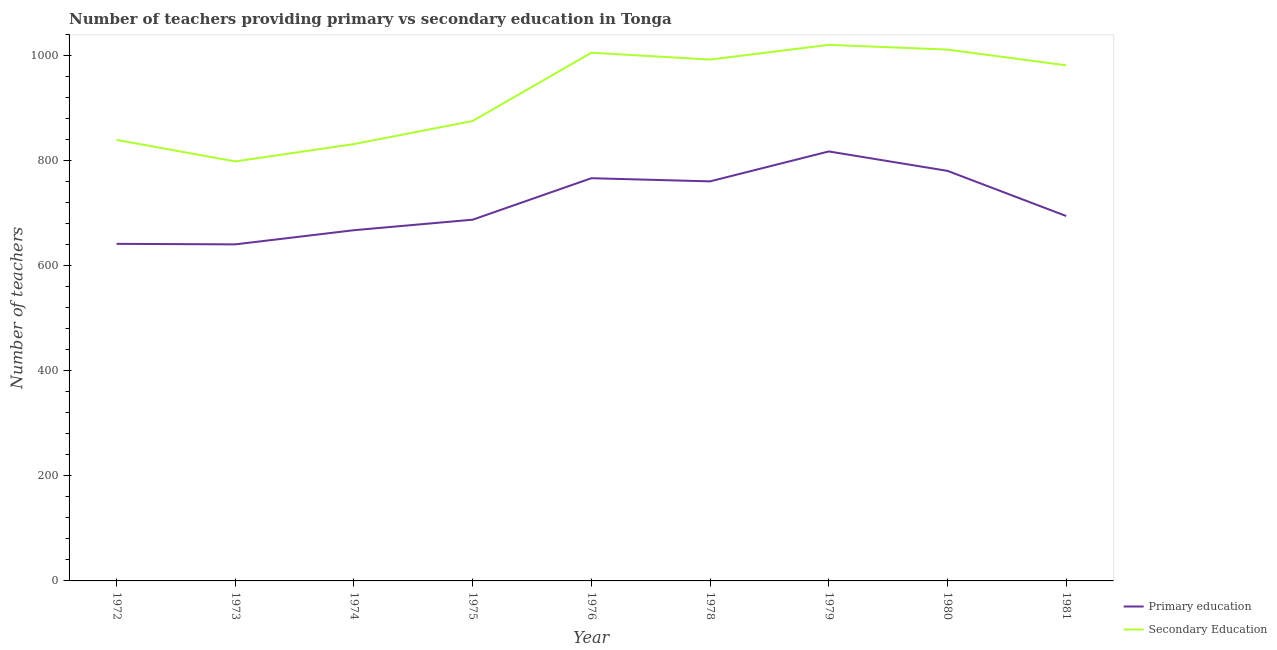How many different coloured lines are there?
Offer a very short reply. 2. Does the line corresponding to number of primary teachers intersect with the line corresponding to number of secondary teachers?
Your response must be concise. No. What is the number of primary teachers in 1975?
Offer a terse response. 688. Across all years, what is the maximum number of primary teachers?
Give a very brief answer. 818. Across all years, what is the minimum number of primary teachers?
Keep it short and to the point. 641. In which year was the number of primary teachers maximum?
Keep it short and to the point. 1979. In which year was the number of primary teachers minimum?
Provide a succinct answer. 1973. What is the total number of primary teachers in the graph?
Make the answer very short. 6461. What is the difference between the number of primary teachers in 1974 and that in 1975?
Make the answer very short. -20. What is the difference between the number of secondary teachers in 1978 and the number of primary teachers in 1972?
Offer a very short reply. 351. What is the average number of secondary teachers per year?
Your answer should be compact. 929. In the year 1981, what is the difference between the number of secondary teachers and number of primary teachers?
Give a very brief answer. 287. What is the ratio of the number of secondary teachers in 1980 to that in 1981?
Offer a very short reply. 1.03. What is the difference between the highest and the second highest number of primary teachers?
Provide a succinct answer. 37. What is the difference between the highest and the lowest number of primary teachers?
Give a very brief answer. 177. In how many years, is the number of secondary teachers greater than the average number of secondary teachers taken over all years?
Provide a short and direct response. 5. Does the number of primary teachers monotonically increase over the years?
Your answer should be compact. No. Is the number of secondary teachers strictly greater than the number of primary teachers over the years?
Provide a short and direct response. Yes. Is the number of secondary teachers strictly less than the number of primary teachers over the years?
Your response must be concise. No. How many years are there in the graph?
Your answer should be very brief. 9. Are the values on the major ticks of Y-axis written in scientific E-notation?
Provide a short and direct response. No. Does the graph contain grids?
Offer a terse response. No. Where does the legend appear in the graph?
Give a very brief answer. Bottom right. What is the title of the graph?
Give a very brief answer. Number of teachers providing primary vs secondary education in Tonga. What is the label or title of the X-axis?
Your response must be concise. Year. What is the label or title of the Y-axis?
Provide a succinct answer. Number of teachers. What is the Number of teachers in Primary education in 1972?
Give a very brief answer. 642. What is the Number of teachers of Secondary Education in 1972?
Keep it short and to the point. 840. What is the Number of teachers of Primary education in 1973?
Ensure brevity in your answer.  641. What is the Number of teachers of Secondary Education in 1973?
Ensure brevity in your answer.  799. What is the Number of teachers of Primary education in 1974?
Offer a very short reply. 668. What is the Number of teachers in Secondary Education in 1974?
Your answer should be compact. 832. What is the Number of teachers in Primary education in 1975?
Make the answer very short. 688. What is the Number of teachers in Secondary Education in 1975?
Provide a short and direct response. 876. What is the Number of teachers of Primary education in 1976?
Ensure brevity in your answer.  767. What is the Number of teachers in Secondary Education in 1976?
Your response must be concise. 1006. What is the Number of teachers in Primary education in 1978?
Keep it short and to the point. 761. What is the Number of teachers of Secondary Education in 1978?
Offer a very short reply. 993. What is the Number of teachers in Primary education in 1979?
Keep it short and to the point. 818. What is the Number of teachers in Secondary Education in 1979?
Keep it short and to the point. 1021. What is the Number of teachers of Primary education in 1980?
Give a very brief answer. 781. What is the Number of teachers of Secondary Education in 1980?
Your answer should be very brief. 1012. What is the Number of teachers of Primary education in 1981?
Offer a very short reply. 695. What is the Number of teachers in Secondary Education in 1981?
Offer a very short reply. 982. Across all years, what is the maximum Number of teachers of Primary education?
Offer a very short reply. 818. Across all years, what is the maximum Number of teachers of Secondary Education?
Offer a terse response. 1021. Across all years, what is the minimum Number of teachers of Primary education?
Offer a very short reply. 641. Across all years, what is the minimum Number of teachers in Secondary Education?
Offer a terse response. 799. What is the total Number of teachers in Primary education in the graph?
Give a very brief answer. 6461. What is the total Number of teachers in Secondary Education in the graph?
Provide a succinct answer. 8361. What is the difference between the Number of teachers in Primary education in 1972 and that in 1973?
Your answer should be compact. 1. What is the difference between the Number of teachers of Secondary Education in 1972 and that in 1973?
Your answer should be very brief. 41. What is the difference between the Number of teachers in Primary education in 1972 and that in 1975?
Offer a terse response. -46. What is the difference between the Number of teachers in Secondary Education in 1972 and that in 1975?
Offer a terse response. -36. What is the difference between the Number of teachers in Primary education in 1972 and that in 1976?
Ensure brevity in your answer.  -125. What is the difference between the Number of teachers of Secondary Education in 1972 and that in 1976?
Ensure brevity in your answer.  -166. What is the difference between the Number of teachers of Primary education in 1972 and that in 1978?
Provide a succinct answer. -119. What is the difference between the Number of teachers of Secondary Education in 1972 and that in 1978?
Offer a very short reply. -153. What is the difference between the Number of teachers of Primary education in 1972 and that in 1979?
Provide a short and direct response. -176. What is the difference between the Number of teachers in Secondary Education in 1972 and that in 1979?
Your answer should be very brief. -181. What is the difference between the Number of teachers in Primary education in 1972 and that in 1980?
Your response must be concise. -139. What is the difference between the Number of teachers of Secondary Education in 1972 and that in 1980?
Your response must be concise. -172. What is the difference between the Number of teachers in Primary education in 1972 and that in 1981?
Your answer should be very brief. -53. What is the difference between the Number of teachers of Secondary Education in 1972 and that in 1981?
Ensure brevity in your answer.  -142. What is the difference between the Number of teachers in Primary education in 1973 and that in 1974?
Your answer should be compact. -27. What is the difference between the Number of teachers of Secondary Education in 1973 and that in 1974?
Provide a short and direct response. -33. What is the difference between the Number of teachers of Primary education in 1973 and that in 1975?
Your answer should be very brief. -47. What is the difference between the Number of teachers in Secondary Education in 1973 and that in 1975?
Ensure brevity in your answer.  -77. What is the difference between the Number of teachers in Primary education in 1973 and that in 1976?
Ensure brevity in your answer.  -126. What is the difference between the Number of teachers of Secondary Education in 1973 and that in 1976?
Keep it short and to the point. -207. What is the difference between the Number of teachers in Primary education in 1973 and that in 1978?
Your answer should be very brief. -120. What is the difference between the Number of teachers of Secondary Education in 1973 and that in 1978?
Provide a short and direct response. -194. What is the difference between the Number of teachers of Primary education in 1973 and that in 1979?
Give a very brief answer. -177. What is the difference between the Number of teachers of Secondary Education in 1973 and that in 1979?
Make the answer very short. -222. What is the difference between the Number of teachers of Primary education in 1973 and that in 1980?
Make the answer very short. -140. What is the difference between the Number of teachers of Secondary Education in 1973 and that in 1980?
Your answer should be compact. -213. What is the difference between the Number of teachers in Primary education in 1973 and that in 1981?
Make the answer very short. -54. What is the difference between the Number of teachers in Secondary Education in 1973 and that in 1981?
Keep it short and to the point. -183. What is the difference between the Number of teachers in Secondary Education in 1974 and that in 1975?
Offer a very short reply. -44. What is the difference between the Number of teachers in Primary education in 1974 and that in 1976?
Provide a succinct answer. -99. What is the difference between the Number of teachers of Secondary Education in 1974 and that in 1976?
Offer a terse response. -174. What is the difference between the Number of teachers in Primary education in 1974 and that in 1978?
Offer a terse response. -93. What is the difference between the Number of teachers of Secondary Education in 1974 and that in 1978?
Provide a short and direct response. -161. What is the difference between the Number of teachers in Primary education in 1974 and that in 1979?
Offer a terse response. -150. What is the difference between the Number of teachers of Secondary Education in 1974 and that in 1979?
Your answer should be compact. -189. What is the difference between the Number of teachers in Primary education in 1974 and that in 1980?
Your answer should be compact. -113. What is the difference between the Number of teachers in Secondary Education in 1974 and that in 1980?
Your response must be concise. -180. What is the difference between the Number of teachers of Secondary Education in 1974 and that in 1981?
Ensure brevity in your answer.  -150. What is the difference between the Number of teachers of Primary education in 1975 and that in 1976?
Give a very brief answer. -79. What is the difference between the Number of teachers in Secondary Education in 1975 and that in 1976?
Offer a very short reply. -130. What is the difference between the Number of teachers in Primary education in 1975 and that in 1978?
Keep it short and to the point. -73. What is the difference between the Number of teachers of Secondary Education in 1975 and that in 1978?
Provide a succinct answer. -117. What is the difference between the Number of teachers of Primary education in 1975 and that in 1979?
Ensure brevity in your answer.  -130. What is the difference between the Number of teachers of Secondary Education in 1975 and that in 1979?
Offer a very short reply. -145. What is the difference between the Number of teachers in Primary education in 1975 and that in 1980?
Your answer should be very brief. -93. What is the difference between the Number of teachers in Secondary Education in 1975 and that in 1980?
Your answer should be compact. -136. What is the difference between the Number of teachers in Primary education in 1975 and that in 1981?
Keep it short and to the point. -7. What is the difference between the Number of teachers in Secondary Education in 1975 and that in 1981?
Give a very brief answer. -106. What is the difference between the Number of teachers of Primary education in 1976 and that in 1978?
Give a very brief answer. 6. What is the difference between the Number of teachers in Primary education in 1976 and that in 1979?
Your response must be concise. -51. What is the difference between the Number of teachers of Secondary Education in 1976 and that in 1981?
Your answer should be compact. 24. What is the difference between the Number of teachers of Primary education in 1978 and that in 1979?
Provide a succinct answer. -57. What is the difference between the Number of teachers in Secondary Education in 1978 and that in 1979?
Make the answer very short. -28. What is the difference between the Number of teachers of Primary education in 1978 and that in 1980?
Provide a short and direct response. -20. What is the difference between the Number of teachers in Primary education in 1978 and that in 1981?
Your response must be concise. 66. What is the difference between the Number of teachers of Primary education in 1979 and that in 1980?
Your answer should be compact. 37. What is the difference between the Number of teachers of Secondary Education in 1979 and that in 1980?
Your answer should be compact. 9. What is the difference between the Number of teachers of Primary education in 1979 and that in 1981?
Your response must be concise. 123. What is the difference between the Number of teachers in Secondary Education in 1979 and that in 1981?
Your answer should be very brief. 39. What is the difference between the Number of teachers in Secondary Education in 1980 and that in 1981?
Offer a terse response. 30. What is the difference between the Number of teachers in Primary education in 1972 and the Number of teachers in Secondary Education in 1973?
Provide a short and direct response. -157. What is the difference between the Number of teachers in Primary education in 1972 and the Number of teachers in Secondary Education in 1974?
Give a very brief answer. -190. What is the difference between the Number of teachers in Primary education in 1972 and the Number of teachers in Secondary Education in 1975?
Make the answer very short. -234. What is the difference between the Number of teachers of Primary education in 1972 and the Number of teachers of Secondary Education in 1976?
Your response must be concise. -364. What is the difference between the Number of teachers of Primary education in 1972 and the Number of teachers of Secondary Education in 1978?
Your response must be concise. -351. What is the difference between the Number of teachers of Primary education in 1972 and the Number of teachers of Secondary Education in 1979?
Offer a very short reply. -379. What is the difference between the Number of teachers of Primary education in 1972 and the Number of teachers of Secondary Education in 1980?
Offer a very short reply. -370. What is the difference between the Number of teachers in Primary education in 1972 and the Number of teachers in Secondary Education in 1981?
Your answer should be very brief. -340. What is the difference between the Number of teachers in Primary education in 1973 and the Number of teachers in Secondary Education in 1974?
Your answer should be compact. -191. What is the difference between the Number of teachers of Primary education in 1973 and the Number of teachers of Secondary Education in 1975?
Offer a very short reply. -235. What is the difference between the Number of teachers in Primary education in 1973 and the Number of teachers in Secondary Education in 1976?
Offer a very short reply. -365. What is the difference between the Number of teachers in Primary education in 1973 and the Number of teachers in Secondary Education in 1978?
Offer a very short reply. -352. What is the difference between the Number of teachers in Primary education in 1973 and the Number of teachers in Secondary Education in 1979?
Keep it short and to the point. -380. What is the difference between the Number of teachers in Primary education in 1973 and the Number of teachers in Secondary Education in 1980?
Your answer should be very brief. -371. What is the difference between the Number of teachers in Primary education in 1973 and the Number of teachers in Secondary Education in 1981?
Provide a succinct answer. -341. What is the difference between the Number of teachers in Primary education in 1974 and the Number of teachers in Secondary Education in 1975?
Provide a succinct answer. -208. What is the difference between the Number of teachers in Primary education in 1974 and the Number of teachers in Secondary Education in 1976?
Your response must be concise. -338. What is the difference between the Number of teachers of Primary education in 1974 and the Number of teachers of Secondary Education in 1978?
Your response must be concise. -325. What is the difference between the Number of teachers in Primary education in 1974 and the Number of teachers in Secondary Education in 1979?
Your answer should be very brief. -353. What is the difference between the Number of teachers of Primary education in 1974 and the Number of teachers of Secondary Education in 1980?
Ensure brevity in your answer.  -344. What is the difference between the Number of teachers of Primary education in 1974 and the Number of teachers of Secondary Education in 1981?
Make the answer very short. -314. What is the difference between the Number of teachers in Primary education in 1975 and the Number of teachers in Secondary Education in 1976?
Your answer should be very brief. -318. What is the difference between the Number of teachers in Primary education in 1975 and the Number of teachers in Secondary Education in 1978?
Offer a very short reply. -305. What is the difference between the Number of teachers in Primary education in 1975 and the Number of teachers in Secondary Education in 1979?
Your answer should be compact. -333. What is the difference between the Number of teachers of Primary education in 1975 and the Number of teachers of Secondary Education in 1980?
Ensure brevity in your answer.  -324. What is the difference between the Number of teachers of Primary education in 1975 and the Number of teachers of Secondary Education in 1981?
Keep it short and to the point. -294. What is the difference between the Number of teachers of Primary education in 1976 and the Number of teachers of Secondary Education in 1978?
Your answer should be compact. -226. What is the difference between the Number of teachers of Primary education in 1976 and the Number of teachers of Secondary Education in 1979?
Offer a very short reply. -254. What is the difference between the Number of teachers of Primary education in 1976 and the Number of teachers of Secondary Education in 1980?
Ensure brevity in your answer.  -245. What is the difference between the Number of teachers of Primary education in 1976 and the Number of teachers of Secondary Education in 1981?
Provide a succinct answer. -215. What is the difference between the Number of teachers of Primary education in 1978 and the Number of teachers of Secondary Education in 1979?
Ensure brevity in your answer.  -260. What is the difference between the Number of teachers of Primary education in 1978 and the Number of teachers of Secondary Education in 1980?
Your answer should be compact. -251. What is the difference between the Number of teachers of Primary education in 1978 and the Number of teachers of Secondary Education in 1981?
Your answer should be compact. -221. What is the difference between the Number of teachers of Primary education in 1979 and the Number of teachers of Secondary Education in 1980?
Provide a succinct answer. -194. What is the difference between the Number of teachers in Primary education in 1979 and the Number of teachers in Secondary Education in 1981?
Offer a very short reply. -164. What is the difference between the Number of teachers of Primary education in 1980 and the Number of teachers of Secondary Education in 1981?
Ensure brevity in your answer.  -201. What is the average Number of teachers of Primary education per year?
Your answer should be very brief. 717.89. What is the average Number of teachers in Secondary Education per year?
Provide a succinct answer. 929. In the year 1972, what is the difference between the Number of teachers of Primary education and Number of teachers of Secondary Education?
Give a very brief answer. -198. In the year 1973, what is the difference between the Number of teachers of Primary education and Number of teachers of Secondary Education?
Ensure brevity in your answer.  -158. In the year 1974, what is the difference between the Number of teachers in Primary education and Number of teachers in Secondary Education?
Offer a terse response. -164. In the year 1975, what is the difference between the Number of teachers of Primary education and Number of teachers of Secondary Education?
Provide a short and direct response. -188. In the year 1976, what is the difference between the Number of teachers in Primary education and Number of teachers in Secondary Education?
Your response must be concise. -239. In the year 1978, what is the difference between the Number of teachers in Primary education and Number of teachers in Secondary Education?
Offer a terse response. -232. In the year 1979, what is the difference between the Number of teachers of Primary education and Number of teachers of Secondary Education?
Provide a short and direct response. -203. In the year 1980, what is the difference between the Number of teachers in Primary education and Number of teachers in Secondary Education?
Your response must be concise. -231. In the year 1981, what is the difference between the Number of teachers in Primary education and Number of teachers in Secondary Education?
Provide a short and direct response. -287. What is the ratio of the Number of teachers in Secondary Education in 1972 to that in 1973?
Provide a short and direct response. 1.05. What is the ratio of the Number of teachers in Primary education in 1972 to that in 1974?
Keep it short and to the point. 0.96. What is the ratio of the Number of teachers of Secondary Education in 1972 to that in 1974?
Provide a short and direct response. 1.01. What is the ratio of the Number of teachers in Primary education in 1972 to that in 1975?
Your response must be concise. 0.93. What is the ratio of the Number of teachers in Secondary Education in 1972 to that in 1975?
Offer a terse response. 0.96. What is the ratio of the Number of teachers of Primary education in 1972 to that in 1976?
Provide a short and direct response. 0.84. What is the ratio of the Number of teachers in Secondary Education in 1972 to that in 1976?
Offer a terse response. 0.83. What is the ratio of the Number of teachers of Primary education in 1972 to that in 1978?
Offer a terse response. 0.84. What is the ratio of the Number of teachers in Secondary Education in 1972 to that in 1978?
Provide a succinct answer. 0.85. What is the ratio of the Number of teachers of Primary education in 1972 to that in 1979?
Your answer should be very brief. 0.78. What is the ratio of the Number of teachers of Secondary Education in 1972 to that in 1979?
Your response must be concise. 0.82. What is the ratio of the Number of teachers in Primary education in 1972 to that in 1980?
Ensure brevity in your answer.  0.82. What is the ratio of the Number of teachers of Secondary Education in 1972 to that in 1980?
Offer a terse response. 0.83. What is the ratio of the Number of teachers of Primary education in 1972 to that in 1981?
Offer a terse response. 0.92. What is the ratio of the Number of teachers of Secondary Education in 1972 to that in 1981?
Make the answer very short. 0.86. What is the ratio of the Number of teachers in Primary education in 1973 to that in 1974?
Make the answer very short. 0.96. What is the ratio of the Number of teachers in Secondary Education in 1973 to that in 1974?
Your response must be concise. 0.96. What is the ratio of the Number of teachers of Primary education in 1973 to that in 1975?
Give a very brief answer. 0.93. What is the ratio of the Number of teachers in Secondary Education in 1973 to that in 1975?
Provide a short and direct response. 0.91. What is the ratio of the Number of teachers of Primary education in 1973 to that in 1976?
Your response must be concise. 0.84. What is the ratio of the Number of teachers in Secondary Education in 1973 to that in 1976?
Offer a very short reply. 0.79. What is the ratio of the Number of teachers of Primary education in 1973 to that in 1978?
Provide a succinct answer. 0.84. What is the ratio of the Number of teachers in Secondary Education in 1973 to that in 1978?
Offer a very short reply. 0.8. What is the ratio of the Number of teachers of Primary education in 1973 to that in 1979?
Keep it short and to the point. 0.78. What is the ratio of the Number of teachers in Secondary Education in 1973 to that in 1979?
Make the answer very short. 0.78. What is the ratio of the Number of teachers in Primary education in 1973 to that in 1980?
Give a very brief answer. 0.82. What is the ratio of the Number of teachers of Secondary Education in 1973 to that in 1980?
Keep it short and to the point. 0.79. What is the ratio of the Number of teachers of Primary education in 1973 to that in 1981?
Make the answer very short. 0.92. What is the ratio of the Number of teachers of Secondary Education in 1973 to that in 1981?
Make the answer very short. 0.81. What is the ratio of the Number of teachers in Primary education in 1974 to that in 1975?
Your answer should be very brief. 0.97. What is the ratio of the Number of teachers of Secondary Education in 1974 to that in 1975?
Offer a terse response. 0.95. What is the ratio of the Number of teachers of Primary education in 1974 to that in 1976?
Provide a succinct answer. 0.87. What is the ratio of the Number of teachers of Secondary Education in 1974 to that in 1976?
Offer a terse response. 0.83. What is the ratio of the Number of teachers of Primary education in 1974 to that in 1978?
Make the answer very short. 0.88. What is the ratio of the Number of teachers of Secondary Education in 1974 to that in 1978?
Your answer should be very brief. 0.84. What is the ratio of the Number of teachers in Primary education in 1974 to that in 1979?
Your answer should be very brief. 0.82. What is the ratio of the Number of teachers of Secondary Education in 1974 to that in 1979?
Make the answer very short. 0.81. What is the ratio of the Number of teachers in Primary education in 1974 to that in 1980?
Your answer should be very brief. 0.86. What is the ratio of the Number of teachers of Secondary Education in 1974 to that in 1980?
Offer a terse response. 0.82. What is the ratio of the Number of teachers of Primary education in 1974 to that in 1981?
Ensure brevity in your answer.  0.96. What is the ratio of the Number of teachers of Secondary Education in 1974 to that in 1981?
Make the answer very short. 0.85. What is the ratio of the Number of teachers in Primary education in 1975 to that in 1976?
Provide a short and direct response. 0.9. What is the ratio of the Number of teachers of Secondary Education in 1975 to that in 1976?
Make the answer very short. 0.87. What is the ratio of the Number of teachers of Primary education in 1975 to that in 1978?
Your answer should be very brief. 0.9. What is the ratio of the Number of teachers of Secondary Education in 1975 to that in 1978?
Your answer should be compact. 0.88. What is the ratio of the Number of teachers in Primary education in 1975 to that in 1979?
Make the answer very short. 0.84. What is the ratio of the Number of teachers of Secondary Education in 1975 to that in 1979?
Provide a short and direct response. 0.86. What is the ratio of the Number of teachers of Primary education in 1975 to that in 1980?
Provide a succinct answer. 0.88. What is the ratio of the Number of teachers of Secondary Education in 1975 to that in 1980?
Your answer should be very brief. 0.87. What is the ratio of the Number of teachers in Primary education in 1975 to that in 1981?
Your answer should be very brief. 0.99. What is the ratio of the Number of teachers in Secondary Education in 1975 to that in 1981?
Make the answer very short. 0.89. What is the ratio of the Number of teachers in Primary education in 1976 to that in 1978?
Your response must be concise. 1.01. What is the ratio of the Number of teachers of Secondary Education in 1976 to that in 1978?
Keep it short and to the point. 1.01. What is the ratio of the Number of teachers of Primary education in 1976 to that in 1979?
Your answer should be compact. 0.94. What is the ratio of the Number of teachers in Secondary Education in 1976 to that in 1979?
Make the answer very short. 0.99. What is the ratio of the Number of teachers in Primary education in 1976 to that in 1980?
Your answer should be very brief. 0.98. What is the ratio of the Number of teachers of Primary education in 1976 to that in 1981?
Ensure brevity in your answer.  1.1. What is the ratio of the Number of teachers of Secondary Education in 1976 to that in 1981?
Give a very brief answer. 1.02. What is the ratio of the Number of teachers in Primary education in 1978 to that in 1979?
Ensure brevity in your answer.  0.93. What is the ratio of the Number of teachers of Secondary Education in 1978 to that in 1979?
Your response must be concise. 0.97. What is the ratio of the Number of teachers of Primary education in 1978 to that in 1980?
Your answer should be compact. 0.97. What is the ratio of the Number of teachers in Secondary Education in 1978 to that in 1980?
Ensure brevity in your answer.  0.98. What is the ratio of the Number of teachers in Primary education in 1978 to that in 1981?
Offer a terse response. 1.09. What is the ratio of the Number of teachers of Secondary Education in 1978 to that in 1981?
Your answer should be compact. 1.01. What is the ratio of the Number of teachers in Primary education in 1979 to that in 1980?
Offer a terse response. 1.05. What is the ratio of the Number of teachers of Secondary Education in 1979 to that in 1980?
Provide a succinct answer. 1.01. What is the ratio of the Number of teachers in Primary education in 1979 to that in 1981?
Provide a succinct answer. 1.18. What is the ratio of the Number of teachers in Secondary Education in 1979 to that in 1981?
Provide a short and direct response. 1.04. What is the ratio of the Number of teachers in Primary education in 1980 to that in 1981?
Keep it short and to the point. 1.12. What is the ratio of the Number of teachers of Secondary Education in 1980 to that in 1981?
Keep it short and to the point. 1.03. What is the difference between the highest and the second highest Number of teachers in Primary education?
Keep it short and to the point. 37. What is the difference between the highest and the second highest Number of teachers of Secondary Education?
Make the answer very short. 9. What is the difference between the highest and the lowest Number of teachers in Primary education?
Give a very brief answer. 177. What is the difference between the highest and the lowest Number of teachers in Secondary Education?
Keep it short and to the point. 222. 